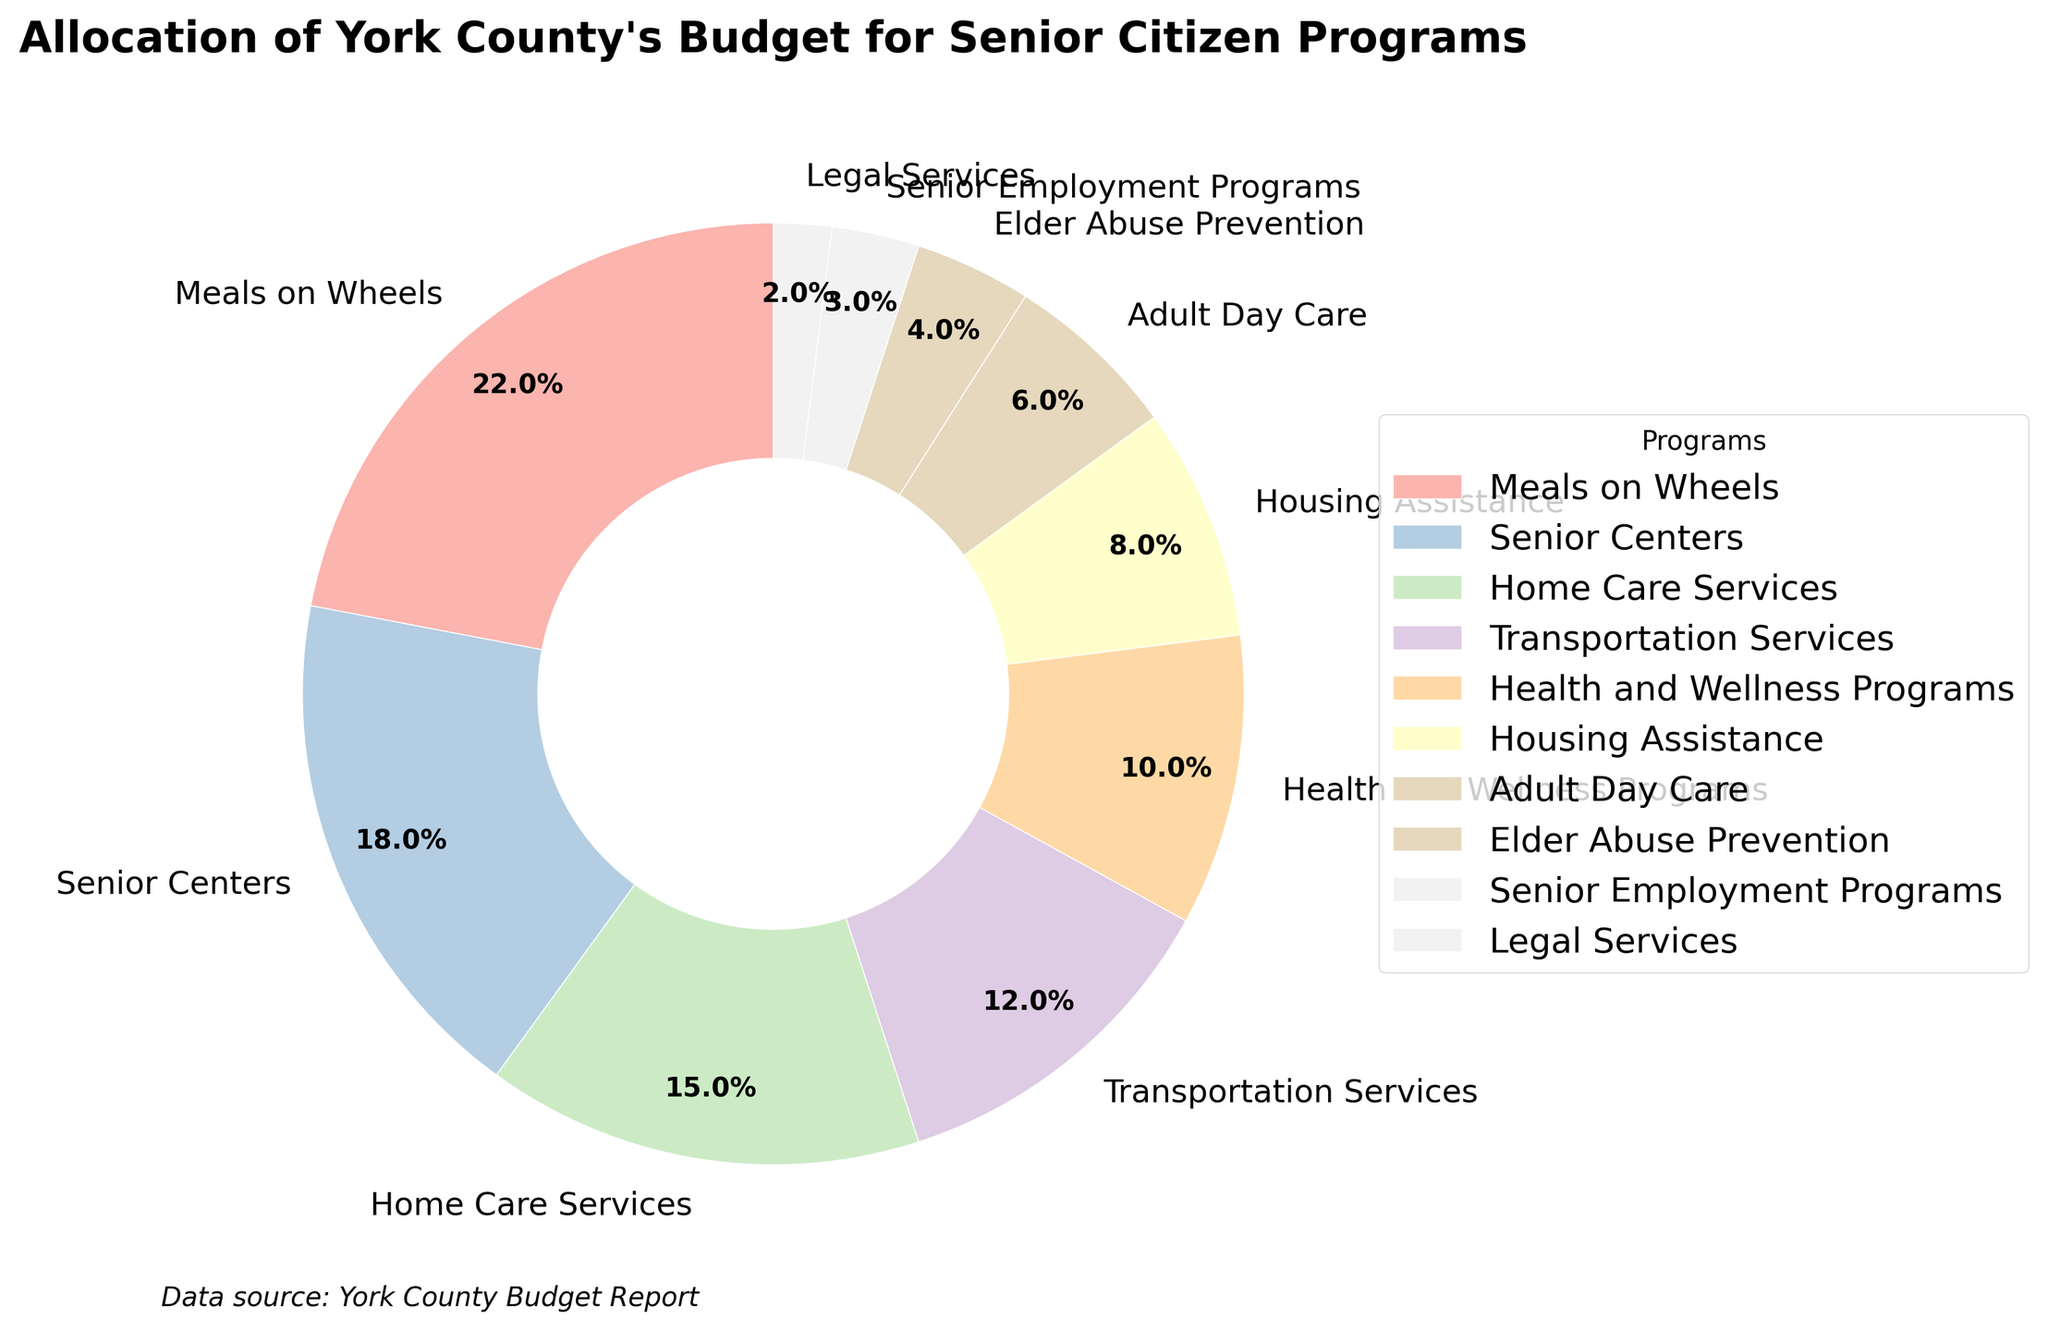What percentage of the budget is allocated to meals on wheels? The percentage allocated to Meals on Wheels is displayed directly on the pie chart segment as 22%.
Answer: 22% How much more of the budget is allocated to senior centers compared to legal services? Senior Centers receive 18% of the budget, while Legal Services receive 2%. The difference is 18% - 2% = 16%.
Answer: 16% Which program receives the least amount of funding? According to the pie chart, Legal Services receive the smallest portion of the budget at 2%.
Answer: Legal Services What's the total percentage of the budget allocated to transportation services and housing assistance combined? Transportation Services receive 12% of the budget, and Housing Assistance receives 8%. Combined, they account for 12% + 8% = 20%.
Answer: 20% How many programs have an allocation greater than or equal to 10% of the budget? By looking at each segment of the pie chart, we see Meals on Wheels (22%), Senior Centers (18%), Home Care Services (15%), Transportation Services (12%), and Health and Wellness Programs (10%) all meet or exceed 10%. This totals 5 programs.
Answer: 5 Which receives a greater percentage of the budget: Adult Day Care or Elder Abuse Prevention? Adult Day Care has 6% of the budget while Elder Abuse Prevention has 4%. Therefore, Adult Day Care receives a greater percentage of the budget.
Answer: Adult Day Care What is the combined budget percentage for programs aimed at in-home assistance (Meals on Wheels, Home Care Services, Housing Assistance)? Meals on Wheels (22%), Home Care Services (15%), and Housing Assistance (8%) together receive 22% + 15% + 8% = 45%.
Answer: 45% Are there more programs allocated at least 5% of the budget or fewer than 5%? Programs with at least 5% are Meals on Wheels (22%), Senior Centers (18%), Home Care Services (15%), Transportation Services (12%), Health and Wellness Programs (10%), Housing Assistance (8%), and Adult Day Care (6%)—totaling 7 programs. Those allocated less than 5% are Elder Abuse Prevention (4%), Senior Employment Programs (3%), and Legal Services (2%)—totaling 3 programs. There are more programs (7) allocated at least 5% than fewer than 5% (3).
Answer: More programs What's the total percentage of the budget allocated to programs related to health and well-being? Meals on Wheels (22%), Home Care Services (15%), Health and Wellness Programs (10%), and Adult Day Care (6%) contribute to health and well-being-related programs. Combined, they account for 22% + 15% + 10% + 6% = 53%.
Answer: 53% Which program comes closest to receiving the average budget percentage across all programs? Summing up all budget percentages gives 100%. There are 10 programs, so the average is 100% / 10 = 10%. The Health and Wellness Programs receive 10%, matching the average exactly.
Answer: Health and Wellness Programs 